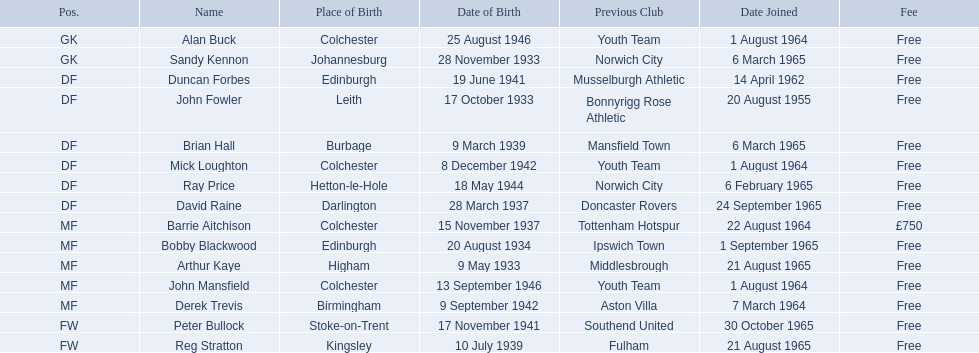When did alan buck become a member of colchester united f.c. in the 1965-66 season? 1 August 1964. When was the final player to join? Peter Bullock. On what date did the initial player join? 20 August 1955. 